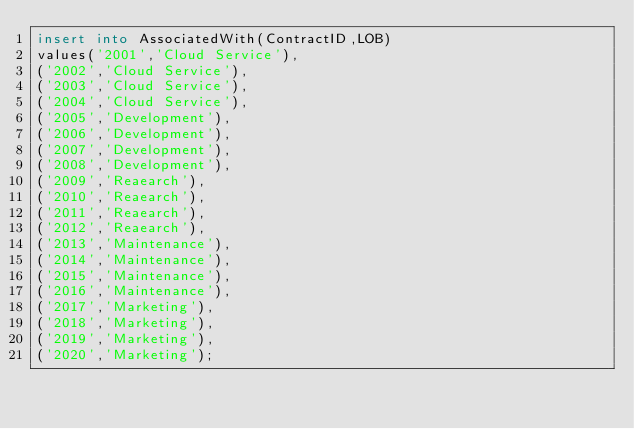Convert code to text. <code><loc_0><loc_0><loc_500><loc_500><_SQL_>insert into AssociatedWith(ContractID,LOB)
values('2001','Cloud Service'),
('2002','Cloud Service'),
('2003','Cloud Service'),
('2004','Cloud Service'),
('2005','Development'),
('2006','Development'),
('2007','Development'),
('2008','Development'),
('2009','Reaearch'),
('2010','Reaearch'),
('2011','Reaearch'),
('2012','Reaearch'),
('2013','Maintenance'),
('2014','Maintenance'),
('2015','Maintenance'),
('2016','Maintenance'),
('2017','Marketing'),
('2018','Marketing'),
('2019','Marketing'),
('2020','Marketing');

</code> 